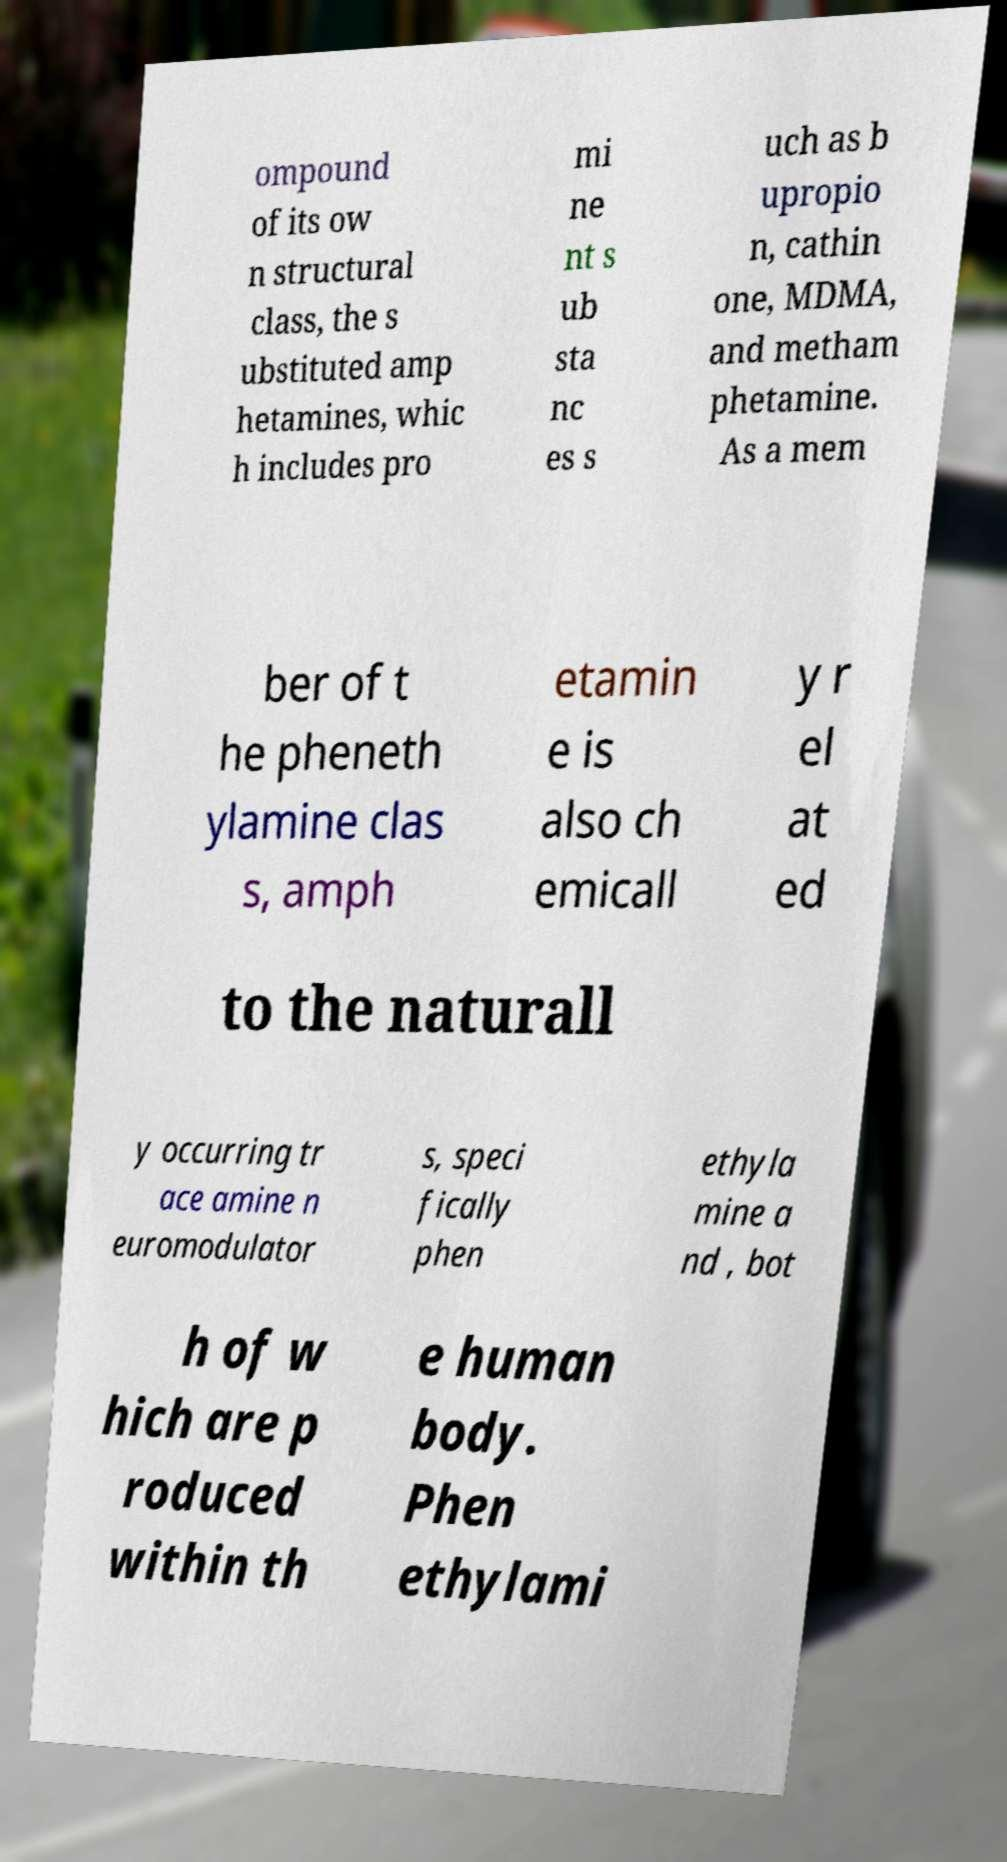Can you accurately transcribe the text from the provided image for me? ompound of its ow n structural class, the s ubstituted amp hetamines, whic h includes pro mi ne nt s ub sta nc es s uch as b upropio n, cathin one, MDMA, and metham phetamine. As a mem ber of t he pheneth ylamine clas s, amph etamin e is also ch emicall y r el at ed to the naturall y occurring tr ace amine n euromodulator s, speci fically phen ethyla mine a nd , bot h of w hich are p roduced within th e human body. Phen ethylami 